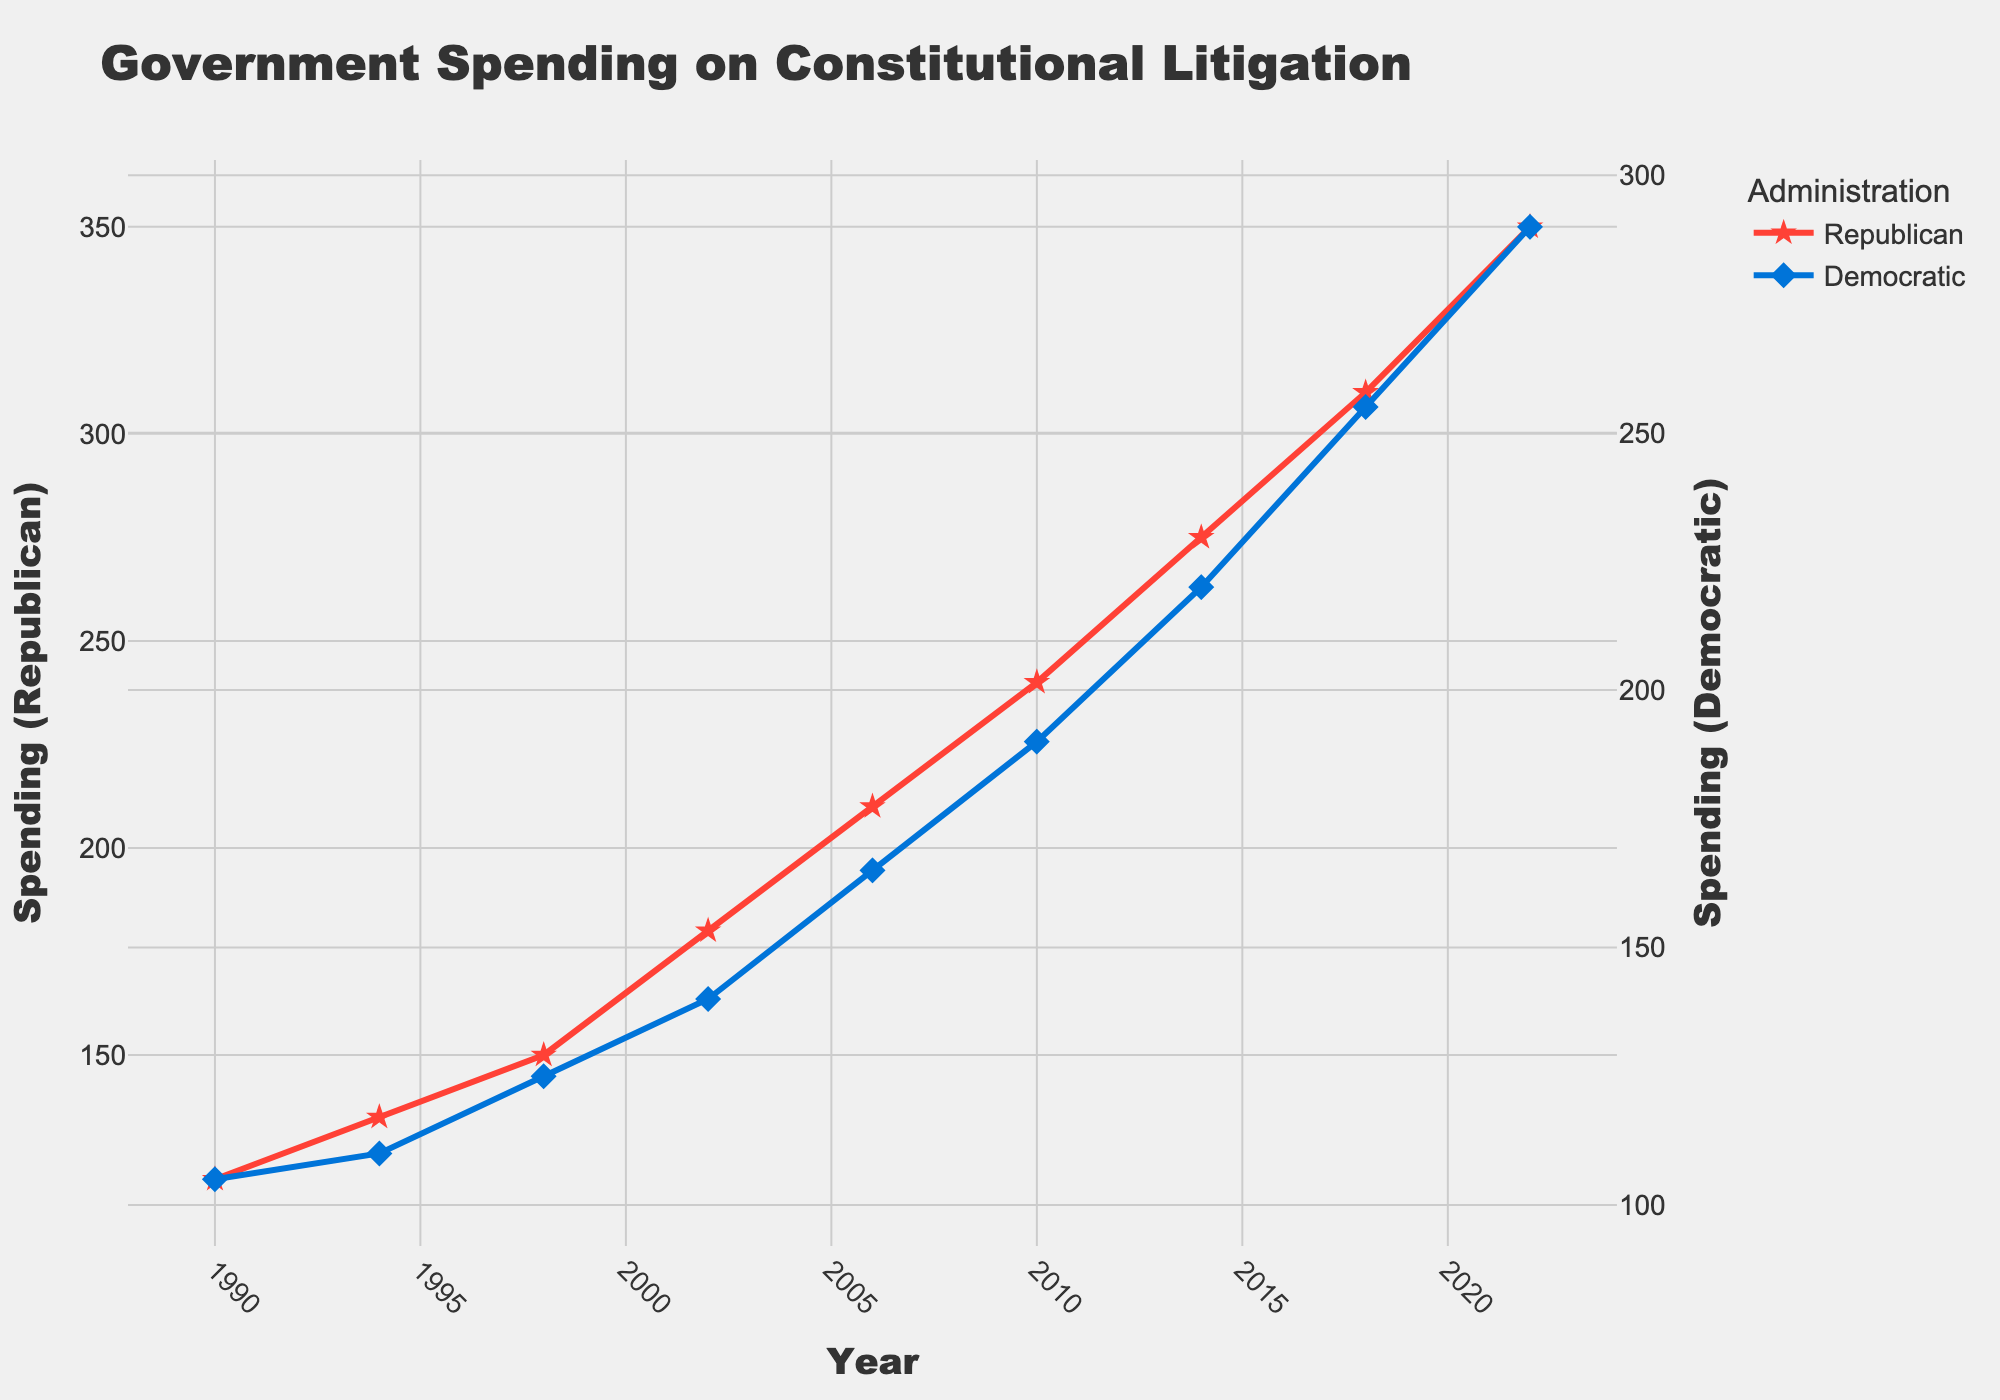Which administration had higher spending on constitutional litigation in 2010? To find out which administration had higher spending in 2010, we compare the values: Republican Administration is 240 and Democratic Administration is 190. Therefore, the Republican Administration had higher spending.
Answer: Republican What was the difference in spending between the Republican and Democratic administrations in 2022? The spending of the Republican Administration in 2022 was 350, and for the Democratic Administration, it was 290. The difference is 350 - 290, which equals 60.
Answer: 60 Did the spending by the Democratic administration ever exceed 250? We look at the timeline for the Democratic Administration. In 2018, the spending was 255, which exceeds 250.
Answer: Yes What is the average spending of the Democratic administration across all years shown? Add all the Democratic spending values: 105 + 110 + 125 + 140 + 165 + 190 + 220 + 255 + 290 = 1600. There are 9 years, so the average is 1600 / 9 = approximately 177.78.
Answer: 177.78 In which year did the Republican administration's spending have the minimum value, and what was it? By looking at the graph, the minimum value for the Republican Administration is 120, which was in 1990, the earliest data point.
Answer: 1990, 120 How did the spending of the Republican administration change from 1998 to 2002? The spending in 1998 was 150, and in 2002 it was 180. Therefore, the spending increased by 180 - 150 = 30.
Answer: Increased by 30 Across which administrations and years did both administrations see an increase in spending? Observing the graph, we see that between the years 1990-1994, 1994-1998, 1998-2002, 2002-2006, 2006-2010, 2010-2014, 2014-2018, and 2018-2022, both Republican and Democratic administrations showed increased spending for each of these periods.
Answer: 1990-1994, 1994-1998, 1998-2002, 2002-2006, 2006-2010, 2010-2014, 2014-2018, 2018-2022 What is the total spending by the Republican administration over all the years shown? We sum all the Republican values: 120 + 135 + 150 + 180 + 210 + 240 + 275 + 310 + 350 = 1970.
Answer: 1970 Are there any years when spending was the same for both administrations? By analyzing the chart, we see that in none of the years the spending values for both administrations are equal.
Answer: No Which year had the highest differential in spending between the Republican and Democratic administrations? Calculating the differential for each year, we find:
1990: 120 - 105 = 15
1994: 135 - 110 = 25
1998: 150 - 125 = 25
2002: 180 - 140 = 40
2006: 210 - 165 = 45
2010: 240 - 190 = 50
2014: 275 - 220 = 55
2018: 310 - 255 = 55
2022: 350 - 290 = 60
Therefore, in 2022, the differential was the highest at 60.
Answer: 2022 